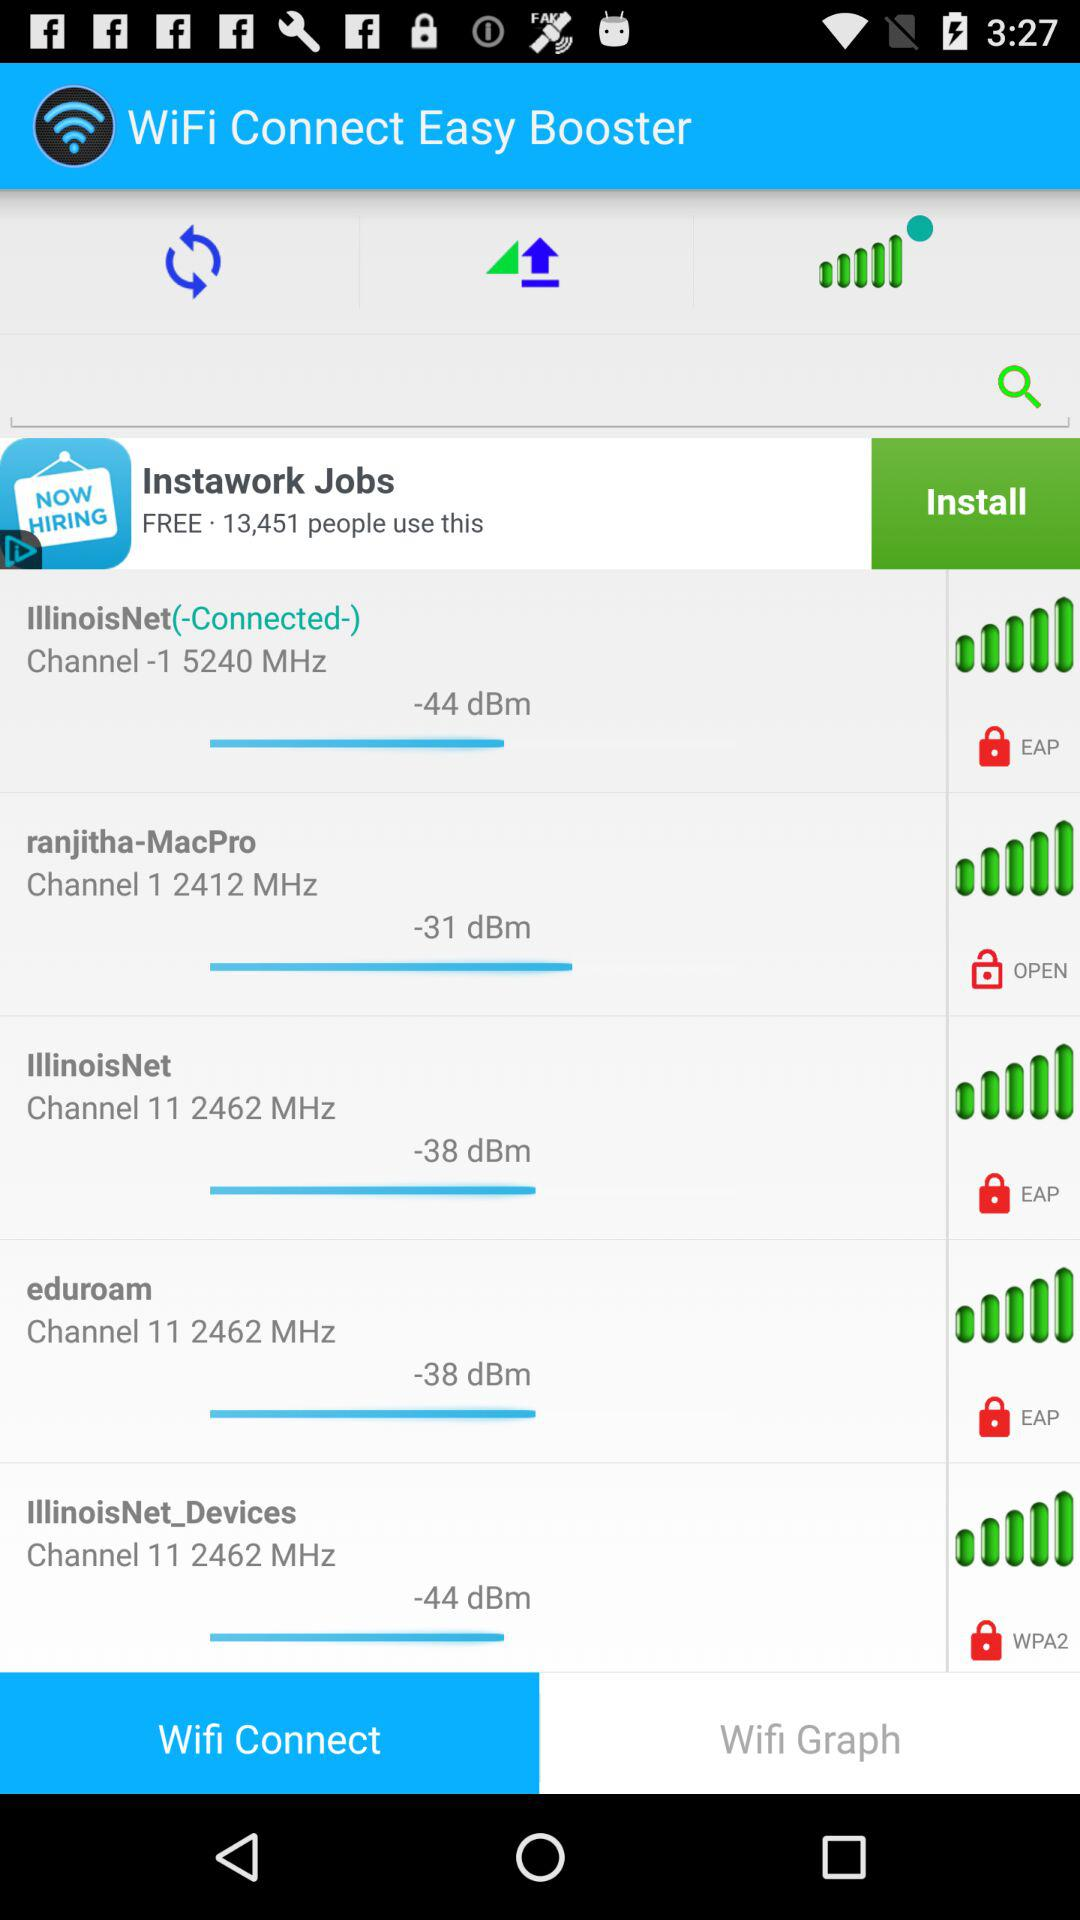What is the name of the application? The name of the application is "WiFi Connect Easy Booster". 